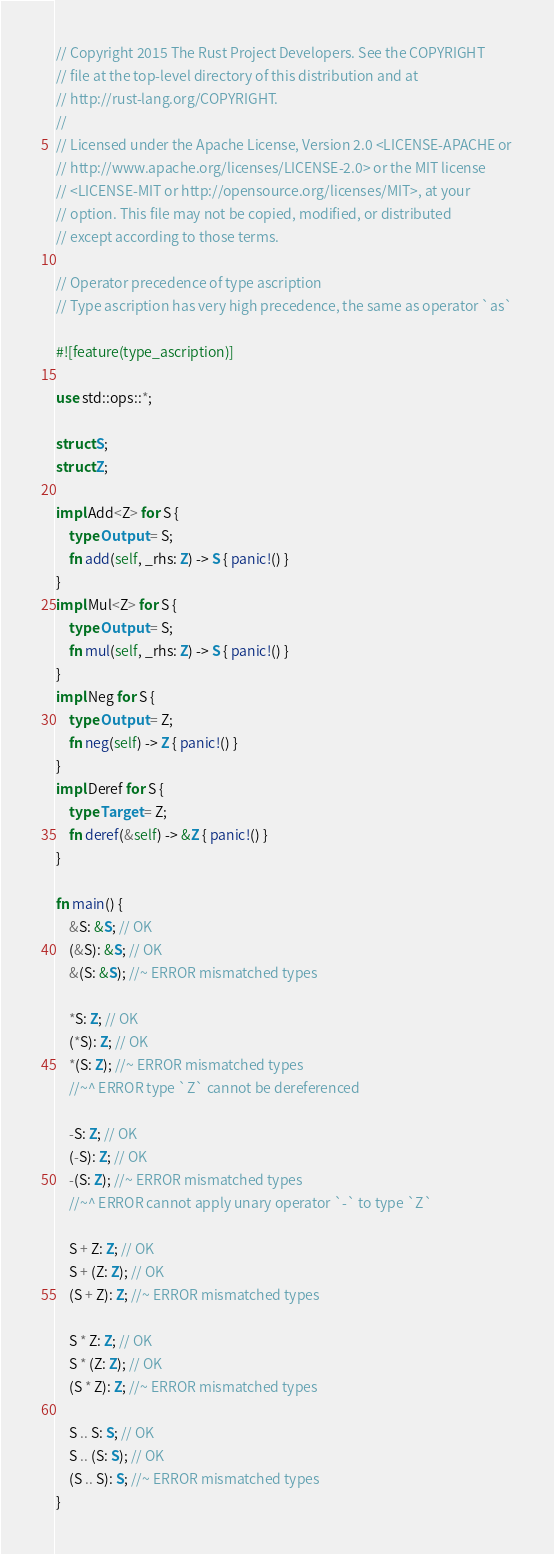Convert code to text. <code><loc_0><loc_0><loc_500><loc_500><_Rust_>// Copyright 2015 The Rust Project Developers. See the COPYRIGHT
// file at the top-level directory of this distribution and at
// http://rust-lang.org/COPYRIGHT.
//
// Licensed under the Apache License, Version 2.0 <LICENSE-APACHE or
// http://www.apache.org/licenses/LICENSE-2.0> or the MIT license
// <LICENSE-MIT or http://opensource.org/licenses/MIT>, at your
// option. This file may not be copied, modified, or distributed
// except according to those terms.

// Operator precedence of type ascription
// Type ascription has very high precedence, the same as operator `as`

#![feature(type_ascription)]

use std::ops::*;

struct S;
struct Z;

impl Add<Z> for S {
    type Output = S;
    fn add(self, _rhs: Z) -> S { panic!() }
}
impl Mul<Z> for S {
    type Output = S;
    fn mul(self, _rhs: Z) -> S { panic!() }
}
impl Neg for S {
    type Output = Z;
    fn neg(self) -> Z { panic!() }
}
impl Deref for S {
    type Target = Z;
    fn deref(&self) -> &Z { panic!() }
}

fn main() {
    &S: &S; // OK
    (&S): &S; // OK
    &(S: &S); //~ ERROR mismatched types

    *S: Z; // OK
    (*S): Z; // OK
    *(S: Z); //~ ERROR mismatched types
    //~^ ERROR type `Z` cannot be dereferenced

    -S: Z; // OK
    (-S): Z; // OK
    -(S: Z); //~ ERROR mismatched types
    //~^ ERROR cannot apply unary operator `-` to type `Z`

    S + Z: Z; // OK
    S + (Z: Z); // OK
    (S + Z): Z; //~ ERROR mismatched types

    S * Z: Z; // OK
    S * (Z: Z); // OK
    (S * Z): Z; //~ ERROR mismatched types

    S .. S: S; // OK
    S .. (S: S); // OK
    (S .. S): S; //~ ERROR mismatched types
}
</code> 